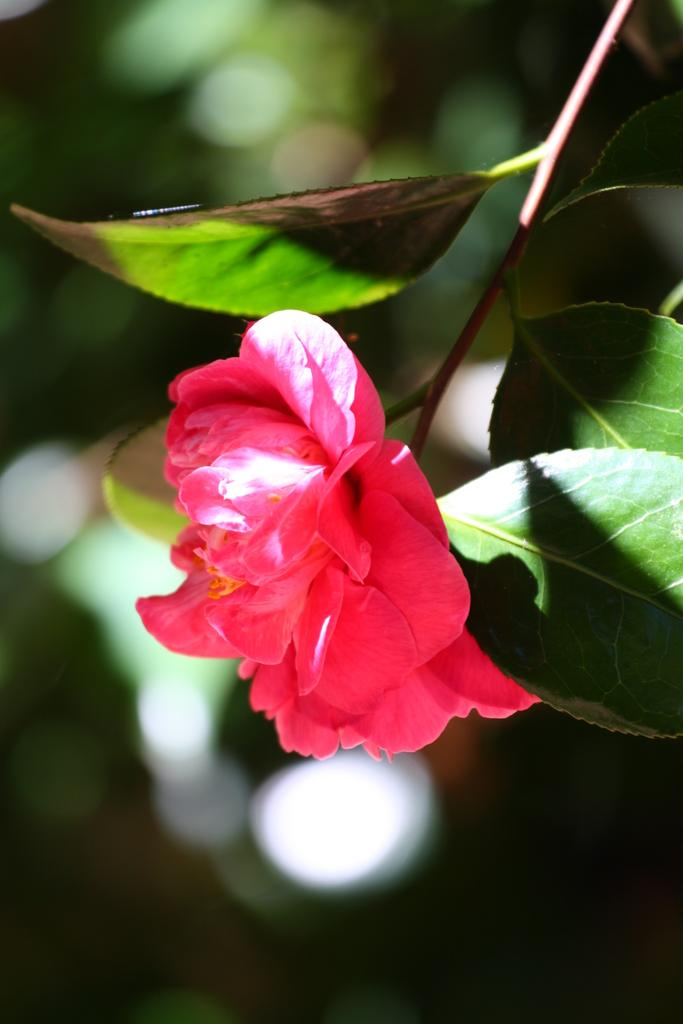What type of plant can be seen in the image? There is a flower in the image. What parts of the plant are visible in the image? There are leaves and a stem in the image. How would you describe the background of the image? The background of the image is blurred. How many friends are helping the laborer in the image? There are no friends or laborers present in the image; it features a flower with leaves and a stem against a blurred background. 